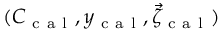<formula> <loc_0><loc_0><loc_500><loc_500>( C _ { c a l } , y _ { c a l } , \vec { \zeta } _ { c a l } )</formula> 